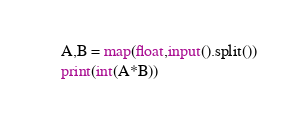Convert code to text. <code><loc_0><loc_0><loc_500><loc_500><_Python_>A,B = map(float,input().split())
print(int(A*B))</code> 